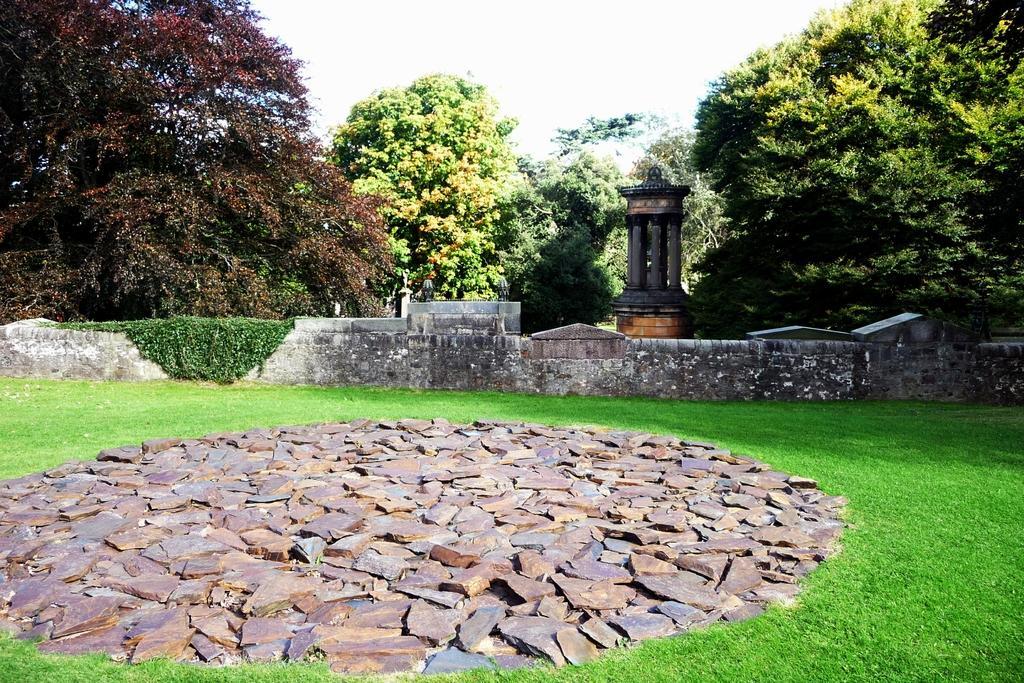Describe this image in one or two sentences. This image is taken outdoors. At the top of the image there is the sky. At the bottom of the image there is a ground with grass on it. There are many stones on the ground. In the background there are many trees with leaves, stems and branches. There is an architecture with pillars. There is a wall and there is a creeper with green leaves. 